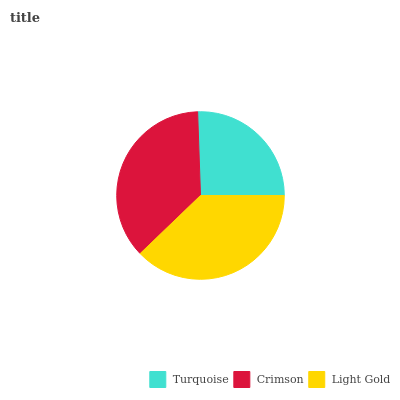Is Turquoise the minimum?
Answer yes or no. Yes. Is Light Gold the maximum?
Answer yes or no. Yes. Is Crimson the minimum?
Answer yes or no. No. Is Crimson the maximum?
Answer yes or no. No. Is Crimson greater than Turquoise?
Answer yes or no. Yes. Is Turquoise less than Crimson?
Answer yes or no. Yes. Is Turquoise greater than Crimson?
Answer yes or no. No. Is Crimson less than Turquoise?
Answer yes or no. No. Is Crimson the high median?
Answer yes or no. Yes. Is Crimson the low median?
Answer yes or no. Yes. Is Turquoise the high median?
Answer yes or no. No. Is Light Gold the low median?
Answer yes or no. No. 